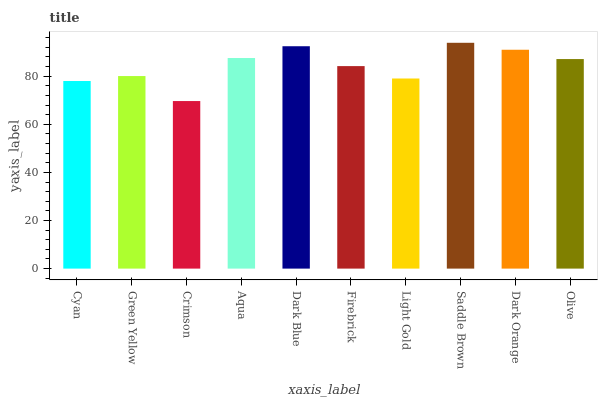Is Green Yellow the minimum?
Answer yes or no. No. Is Green Yellow the maximum?
Answer yes or no. No. Is Green Yellow greater than Cyan?
Answer yes or no. Yes. Is Cyan less than Green Yellow?
Answer yes or no. Yes. Is Cyan greater than Green Yellow?
Answer yes or no. No. Is Green Yellow less than Cyan?
Answer yes or no. No. Is Olive the high median?
Answer yes or no. Yes. Is Firebrick the low median?
Answer yes or no. Yes. Is Saddle Brown the high median?
Answer yes or no. No. Is Crimson the low median?
Answer yes or no. No. 